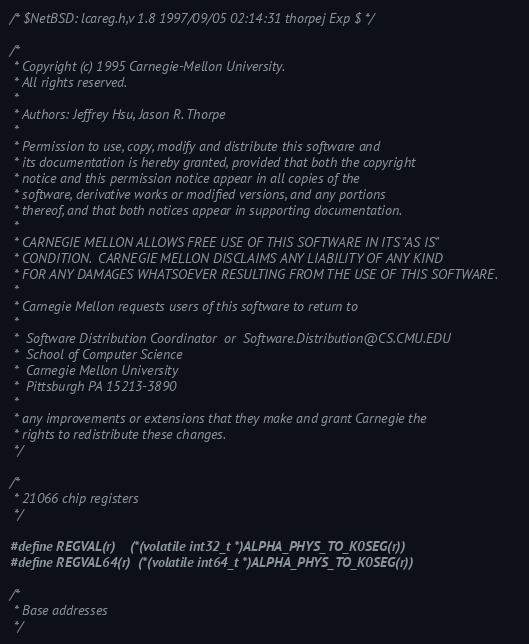Convert code to text. <code><loc_0><loc_0><loc_500><loc_500><_C_>/* $NetBSD: lcareg.h,v 1.8 1997/09/05 02:14:31 thorpej Exp $ */

/*
 * Copyright (c) 1995 Carnegie-Mellon University.
 * All rights reserved.
 *
 * Authors: Jeffrey Hsu, Jason R. Thorpe
 * 
 * Permission to use, copy, modify and distribute this software and
 * its documentation is hereby granted, provided that both the copyright
 * notice and this permission notice appear in all copies of the
 * software, derivative works or modified versions, and any portions
 * thereof, and that both notices appear in supporting documentation.
 * 
 * CARNEGIE MELLON ALLOWS FREE USE OF THIS SOFTWARE IN ITS "AS IS" 
 * CONDITION.  CARNEGIE MELLON DISCLAIMS ANY LIABILITY OF ANY KIND 
 * FOR ANY DAMAGES WHATSOEVER RESULTING FROM THE USE OF THIS SOFTWARE.
 * 
 * Carnegie Mellon requests users of this software to return to
 *
 *  Software Distribution Coordinator  or  Software.Distribution@CS.CMU.EDU
 *  School of Computer Science
 *  Carnegie Mellon University
 *  Pittsburgh PA 15213-3890
 *
 * any improvements or extensions that they make and grant Carnegie the
 * rights to redistribute these changes.
 */

/*
 * 21066 chip registers
 */

#define REGVAL(r)	(*(volatile int32_t *)ALPHA_PHYS_TO_K0SEG(r))
#define REGVAL64(r)	(*(volatile int64_t *)ALPHA_PHYS_TO_K0SEG(r))

/*
 * Base addresses
 */</code> 